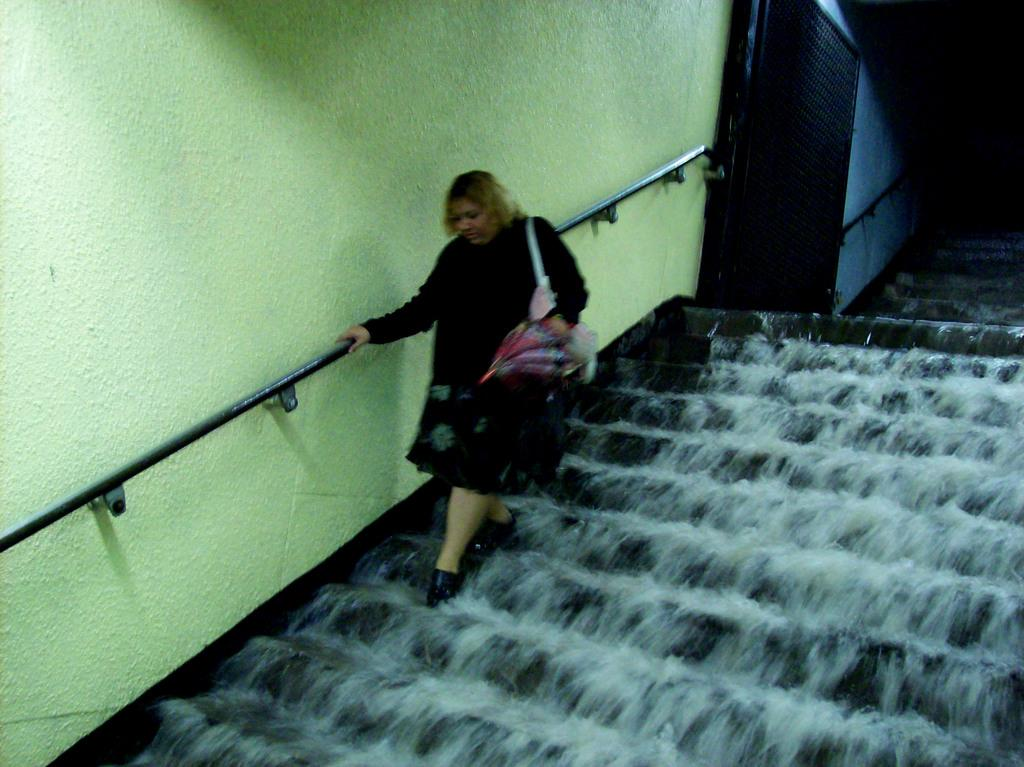What type of structure can be seen in the image? There is a wall in the image. What material is used for the rods in the image? Metal rods are present in the image. Is there an entrance visible in the image? Yes, there is a door in the image. What natural element is visible in the image? Water is visible in the image. What is the woman in the image doing? The woman is climbing on the steps. Can you determine the time of day when the image was taken? The image was likely taken during the day, as there is sufficient light. How many cows are present in the image? There are no cows present in the image. Can you tell me how the woman plans to join the group of friends in the image? There is no group of friends present in the image, and the woman is already climbing the steps. 